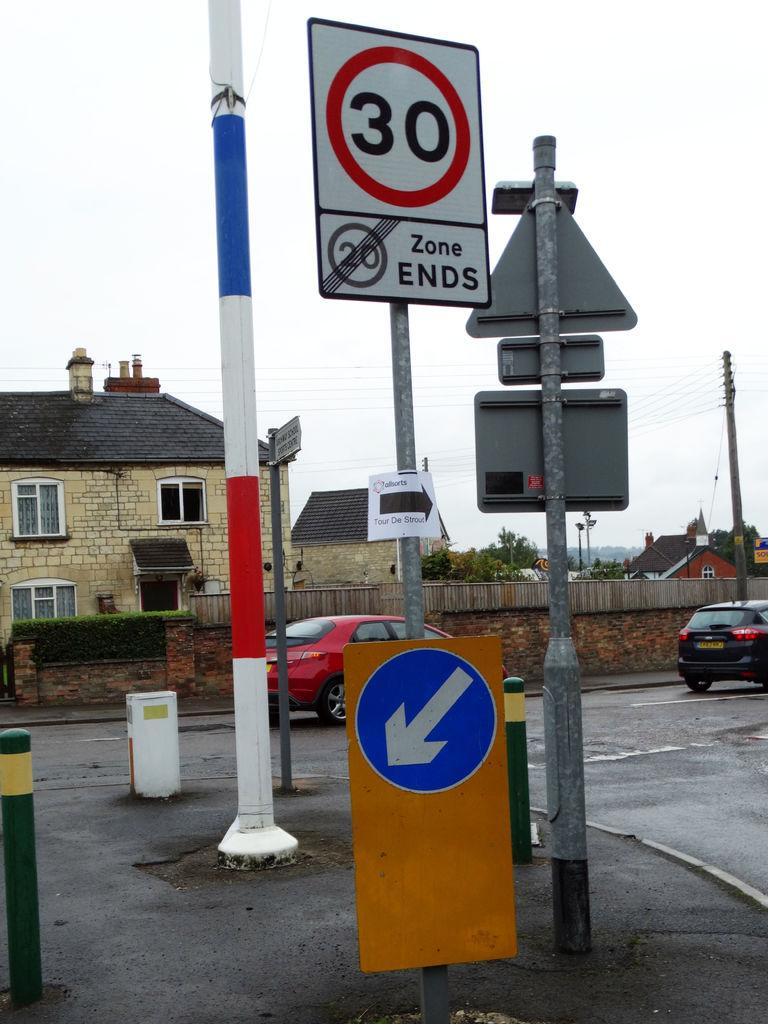Provide a one-sentence caption for the provided image. The road sign warns drivers that the 20 mph zone ends. 